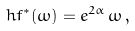Convert formula to latex. <formula><loc_0><loc_0><loc_500><loc_500>\ h f ^ { \ast } ( \omega ) = e ^ { 2 \alpha } \, \omega \, ,</formula> 